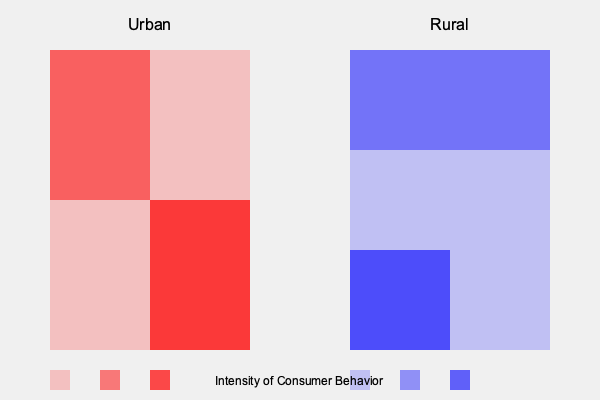Based on the heat maps representing urban and rural consumer behavior patterns, which area shows a more concentrated and intense consumer behavior in a specific region, and how might this relate to societal structures and economic activities in these areas? To analyze the heat maps and answer the question, let's follow these steps:

1. Observe the urban heat map (left):
   - It shows varying intensities of red across different areas.
   - The top-left quadrant has medium intensity.
   - The bottom-right quadrant has the highest intensity.
   - Other areas have lower intensities.

2. Observe the rural heat map (right):
   - It shows varying intensities of blue across different areas.
   - The top half has medium intensity across the entire width.
   - The bottom-left quadrant has the highest intensity.
   - Other areas have lower intensities.

3. Compare the concentration of high-intensity areas:
   - Urban: High intensity is concentrated in one quadrant (bottom-right).
   - Rural: High intensity is spread across the top half and one bottom quadrant.

4. Interpret the patterns:
   - Urban areas show more concentrated, intense consumer behavior in a specific region.
   - Rural areas show more spread out, less concentrated consumer behavior.

5. Relate to societal structures and economic activities:
   - Urban concentration might indicate:
     a) Centralized business districts or shopping areas
     b) Higher population density in specific neighborhoods
     c) Socioeconomic divisions within the urban landscape
   - Rural spread might indicate:
     a) More dispersed economic activities
     b) Lower overall population density
     c) More homogeneous socioeconomic conditions across the area

The urban heat map shows a more concentrated and intense consumer behavior pattern in a specific region compared to the rural heat map. This reflects the tendency of urban areas to have centralized economic hubs, diverse neighborhoods, and potentially more pronounced socioeconomic divisions.
Answer: Urban area, reflecting centralized economic activity and potential socioeconomic divisions. 